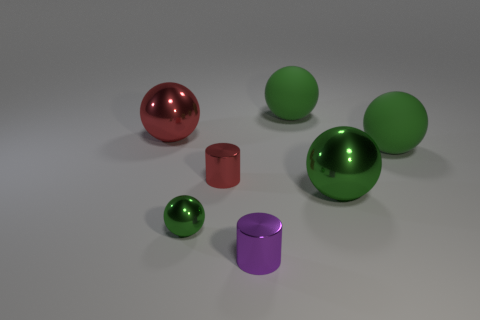How many green spheres must be subtracted to get 2 green spheres? 2 Subtract all purple blocks. How many green balls are left? 4 Subtract all red spheres. How many spheres are left? 4 Subtract all red balls. How many balls are left? 4 Subtract all brown spheres. Subtract all green cylinders. How many spheres are left? 5 Add 3 red metal objects. How many objects exist? 10 Subtract all cylinders. How many objects are left? 5 Add 4 purple things. How many purple things are left? 5 Add 4 large brown matte cubes. How many large brown matte cubes exist? 4 Subtract 0 brown spheres. How many objects are left? 7 